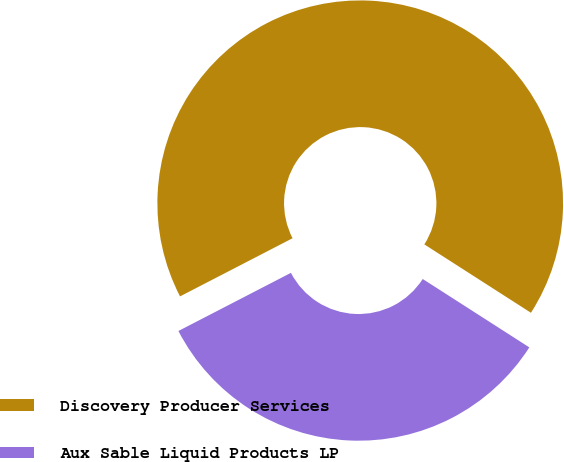Convert chart. <chart><loc_0><loc_0><loc_500><loc_500><pie_chart><fcel>Discovery Producer Services<fcel>Aux Sable Liquid Products LP<nl><fcel>66.67%<fcel>33.33%<nl></chart> 